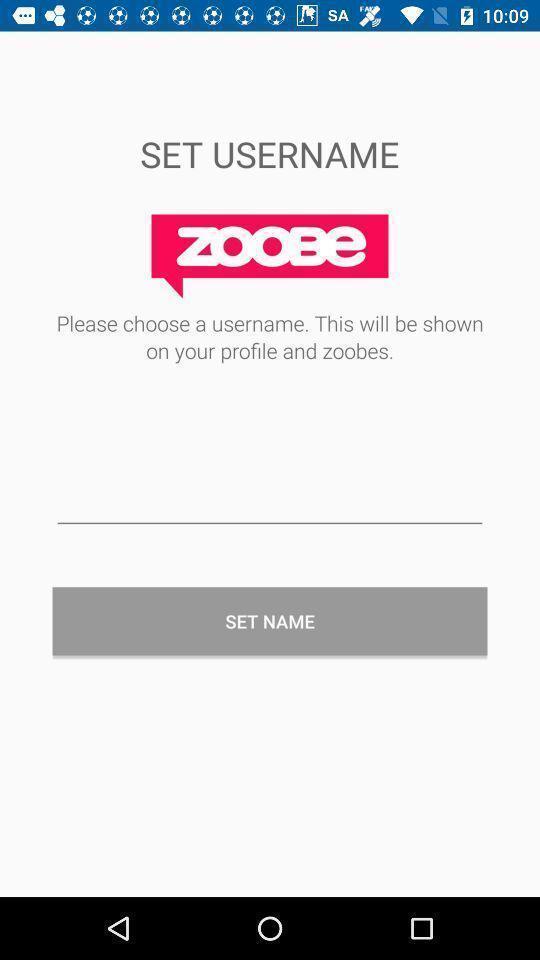Please provide a description for this image. Username setup page. 